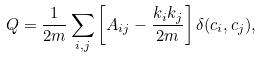<formula> <loc_0><loc_0><loc_500><loc_500>Q = \frac { 1 } { 2 m } \sum _ { i , j } \left [ A _ { i j } - \frac { k _ { i } k _ { j } } { 2 m } \right ] \delta ( c _ { i } , c _ { j } ) ,</formula> 